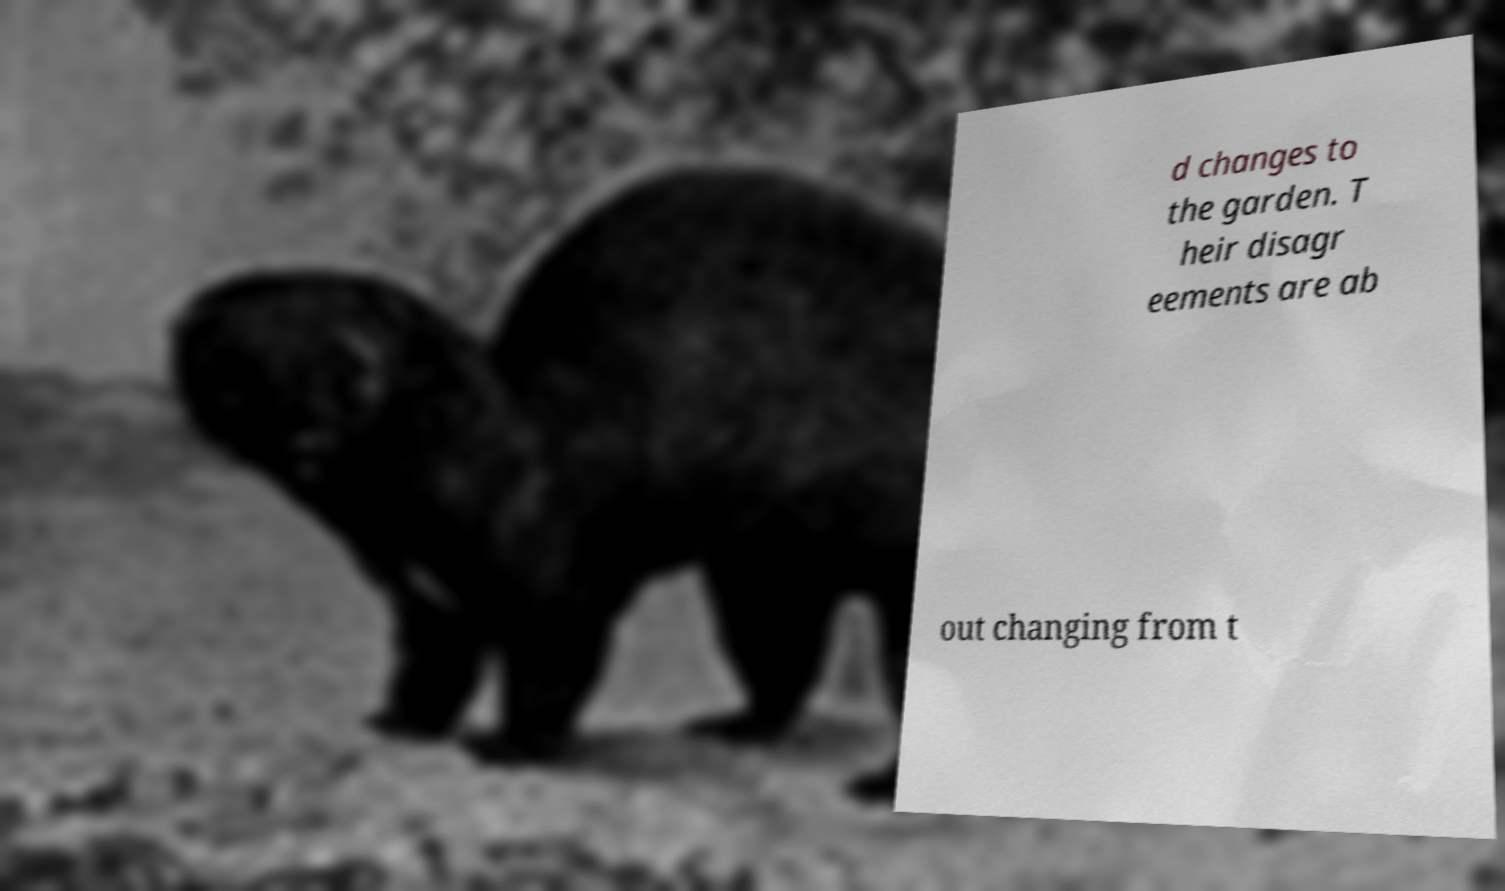Please identify and transcribe the text found in this image. d changes to the garden. T heir disagr eements are ab out changing from t 